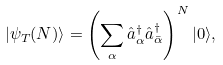Convert formula to latex. <formula><loc_0><loc_0><loc_500><loc_500>| \psi _ { T } ( N ) \rangle = \left ( \sum _ { \alpha } \hat { a } ^ { \dagger } _ { \alpha } \hat { a } ^ { \dagger } _ { \bar { \alpha } } \right ) ^ { N } | 0 \rangle ,</formula> 